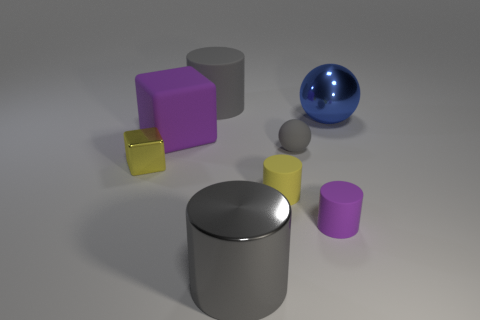Add 2 tiny gray matte spheres. How many objects exist? 10 Subtract all cubes. How many objects are left? 6 Subtract all large purple things. Subtract all metal cylinders. How many objects are left? 6 Add 8 tiny cubes. How many tiny cubes are left? 9 Add 3 gray metal things. How many gray metal things exist? 4 Subtract 0 blue cylinders. How many objects are left? 8 